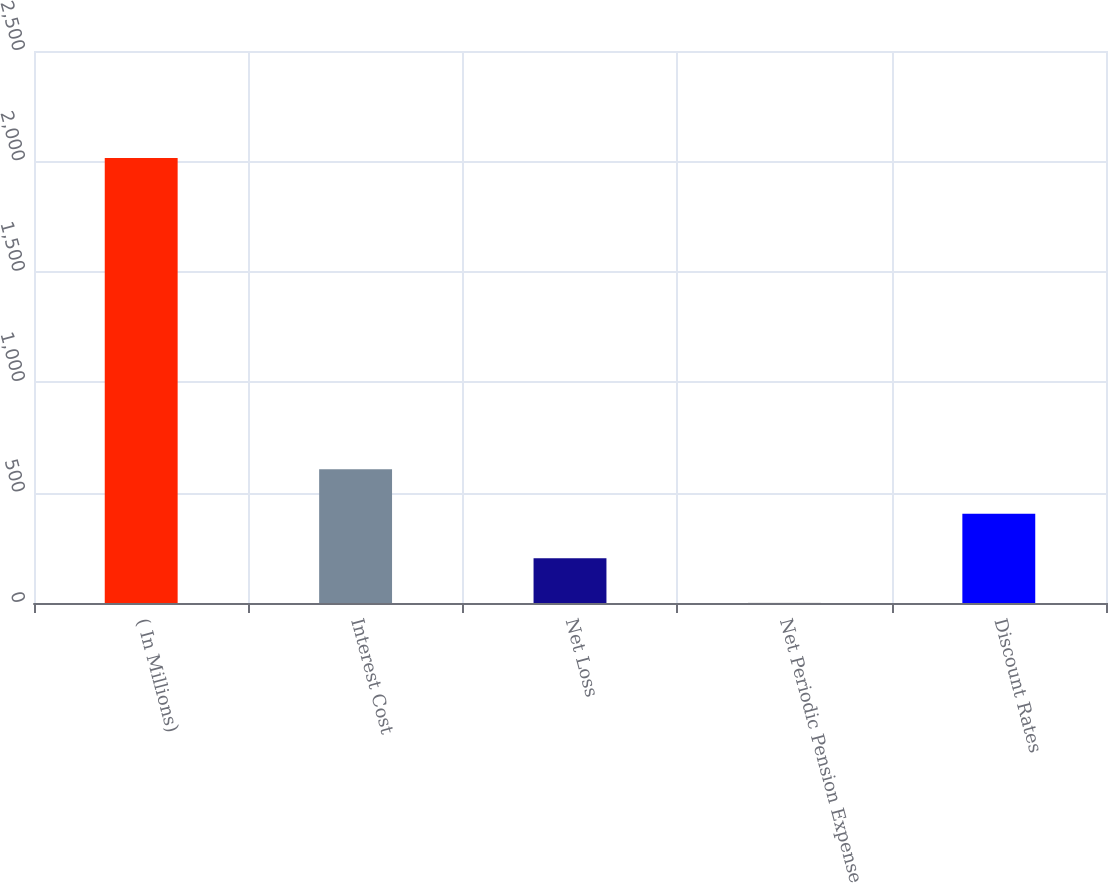<chart> <loc_0><loc_0><loc_500><loc_500><bar_chart><fcel>( In Millions)<fcel>Interest Cost<fcel>Net Loss<fcel>Net Periodic Pension Expense<fcel>Discount Rates<nl><fcel>2015<fcel>605.41<fcel>202.67<fcel>1.3<fcel>404.04<nl></chart> 